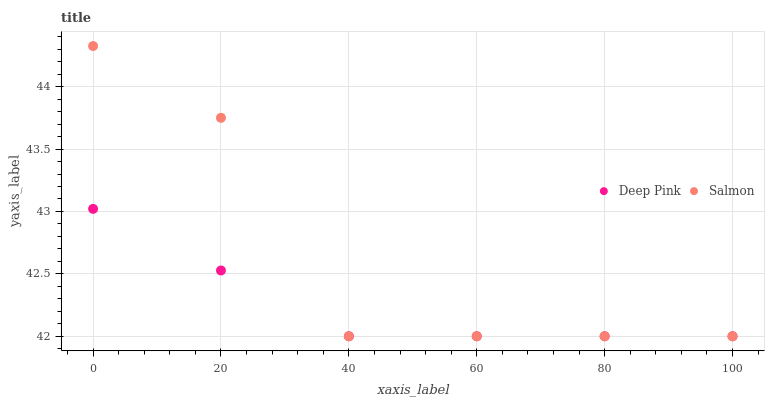Does Deep Pink have the minimum area under the curve?
Answer yes or no. Yes. Does Salmon have the maximum area under the curve?
Answer yes or no. Yes. Does Salmon have the minimum area under the curve?
Answer yes or no. No. Is Deep Pink the smoothest?
Answer yes or no. Yes. Is Salmon the roughest?
Answer yes or no. Yes. Is Salmon the smoothest?
Answer yes or no. No. Does Deep Pink have the lowest value?
Answer yes or no. Yes. Does Salmon have the highest value?
Answer yes or no. Yes. Does Deep Pink intersect Salmon?
Answer yes or no. Yes. Is Deep Pink less than Salmon?
Answer yes or no. No. Is Deep Pink greater than Salmon?
Answer yes or no. No. 